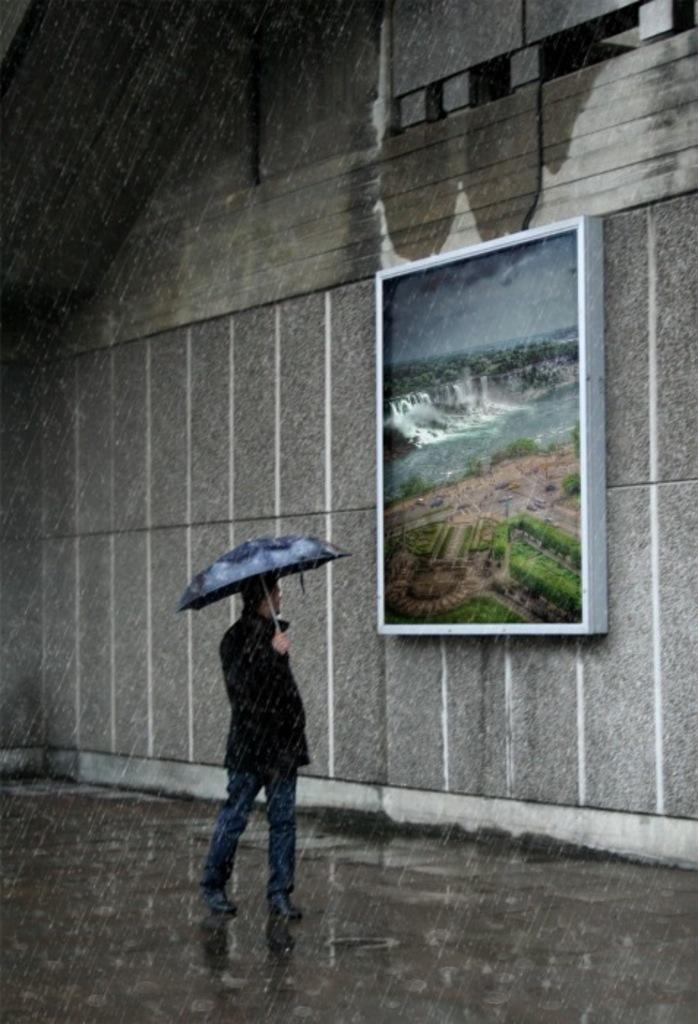What is the main subject of the image? There is a man standing in the center of the image. What is the man holding in the image? The man is holding an umbrella. What can be seen in the background of the image? There is a board placed on a wall in the background of the image. What is visible at the bottom of the image? There is water visible at the bottom of the image. What type of appliance is the man using to cook in the image? There is no appliance or cooking activity present in the image. 